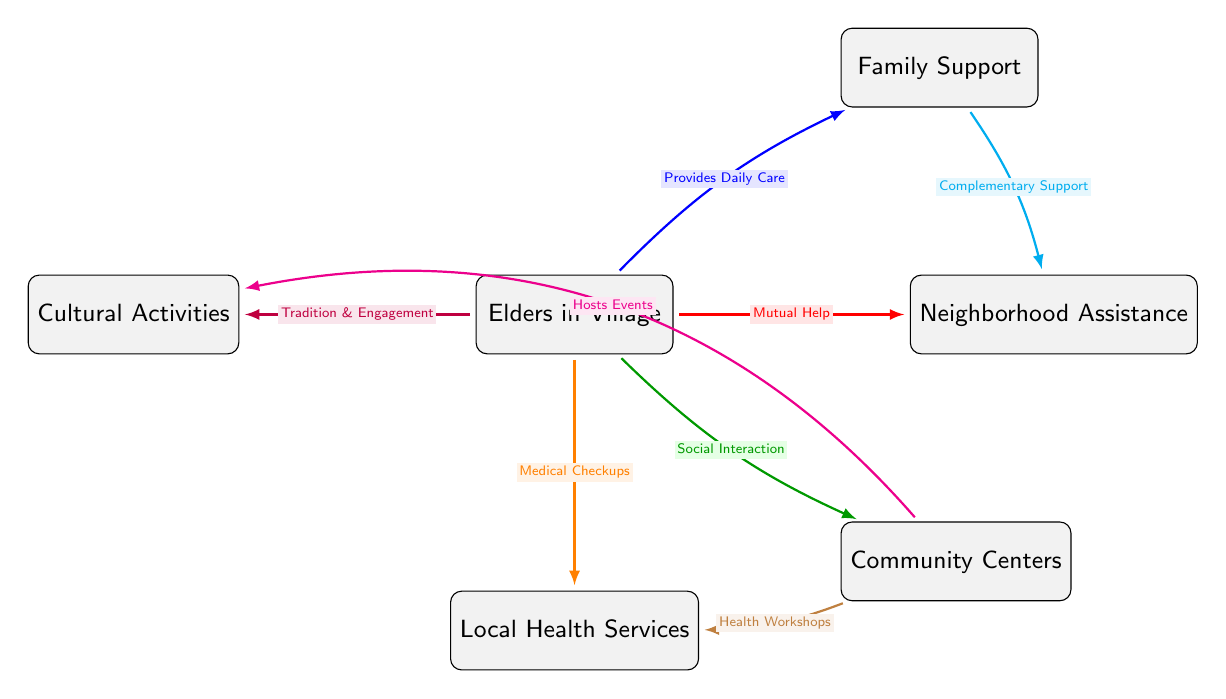What is the main entity in the diagram? The diagram consists of various entities, but the main entity is clearly labeled as "Elders in Village," which serves as the central figure linking different support networks.
Answer: Elders in Village How many types of support are identified for the elders? By analyzing the diagram, we can count six distinct forms of support illustrated, each coming from different entities connected to the elders.
Answer: Six What kind of assistance comes from the neighborhood? The diagram indicates that the neighborhood provides "Mutual Help" to the elders, which is a direct link identified in the relationships shown.
Answer: Mutual Help Which entity is responsible for hosting events according to the diagram? The "Community Centers" are shown in the diagram to connect with "Cultural Activities" through the relationship labeled "Hosts Events," highlighting their role in organizing community engagement.
Answer: Community Centers What type of services do local health services provide to the elders? The local health services are connected to the elders with the relationship labeled "Medical Checkups," indicating the specific support they offer.
Answer: Medical Checkups How does family support interact with neighborhood assistance? The relationship is depicted in the diagram as "Complementary Support," which shows that family support plays a significant role in enhancing the neighborhood's assistance to elders.
Answer: Complementary Support Which entity is associated with social interaction for the elders? The "Community Centers" are indicated to facilitate "Social Interaction" with the elders, linking their communal activities to the welfare of the elderly.
Answer: Community Centers What is indicated as a form of engagement stemming from tradition? The diagram connects cultural activities with the elders through "Tradition & Engagement," portraying a clear relationship that emphasizes cultural connections.
Answer: Tradition & Engagement Which support type is also involved in health workshops? The "Community Centers" provide links to "Health Workshops" as part of their offerings to support the elders, as shown in the diagram's connections.
Answer: Health Workshops 